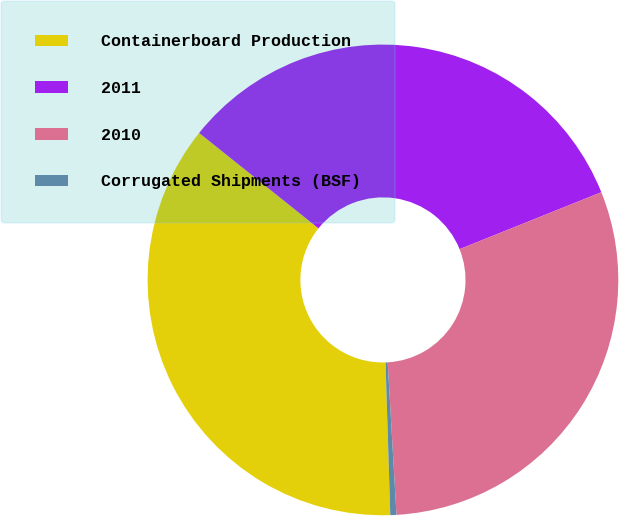<chart> <loc_0><loc_0><loc_500><loc_500><pie_chart><fcel>Containerboard Production<fcel>2011<fcel>2010<fcel>Corrugated Shipments (BSF)<nl><fcel>36.23%<fcel>33.19%<fcel>30.16%<fcel>0.42%<nl></chart> 